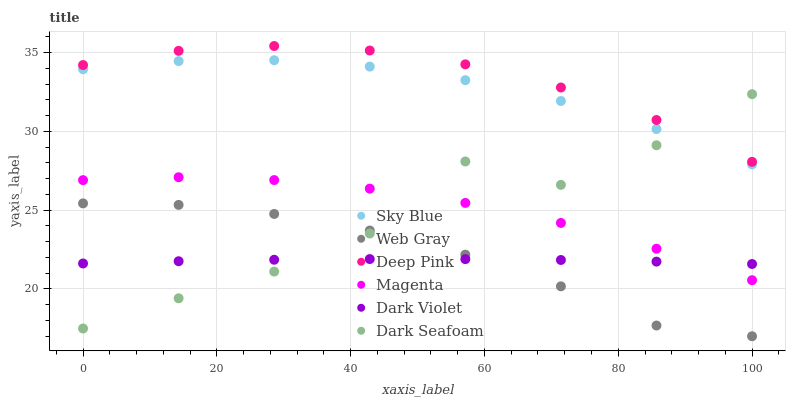Does Dark Violet have the minimum area under the curve?
Answer yes or no. Yes. Does Deep Pink have the maximum area under the curve?
Answer yes or no. Yes. Does Dark Seafoam have the minimum area under the curve?
Answer yes or no. No. Does Dark Seafoam have the maximum area under the curve?
Answer yes or no. No. Is Dark Violet the smoothest?
Answer yes or no. Yes. Is Dark Seafoam the roughest?
Answer yes or no. Yes. Is Dark Seafoam the smoothest?
Answer yes or no. No. Is Dark Violet the roughest?
Answer yes or no. No. Does Web Gray have the lowest value?
Answer yes or no. Yes. Does Dark Violet have the lowest value?
Answer yes or no. No. Does Deep Pink have the highest value?
Answer yes or no. Yes. Does Dark Seafoam have the highest value?
Answer yes or no. No. Is Web Gray less than Deep Pink?
Answer yes or no. Yes. Is Sky Blue greater than Magenta?
Answer yes or no. Yes. Does Dark Violet intersect Dark Seafoam?
Answer yes or no. Yes. Is Dark Violet less than Dark Seafoam?
Answer yes or no. No. Is Dark Violet greater than Dark Seafoam?
Answer yes or no. No. Does Web Gray intersect Deep Pink?
Answer yes or no. No. 